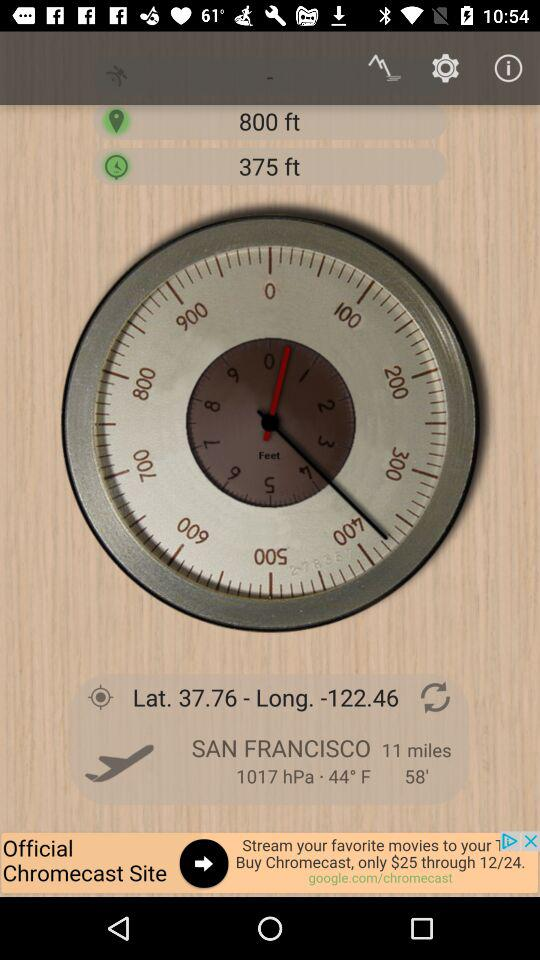What is the location? The location is San Francisco. 